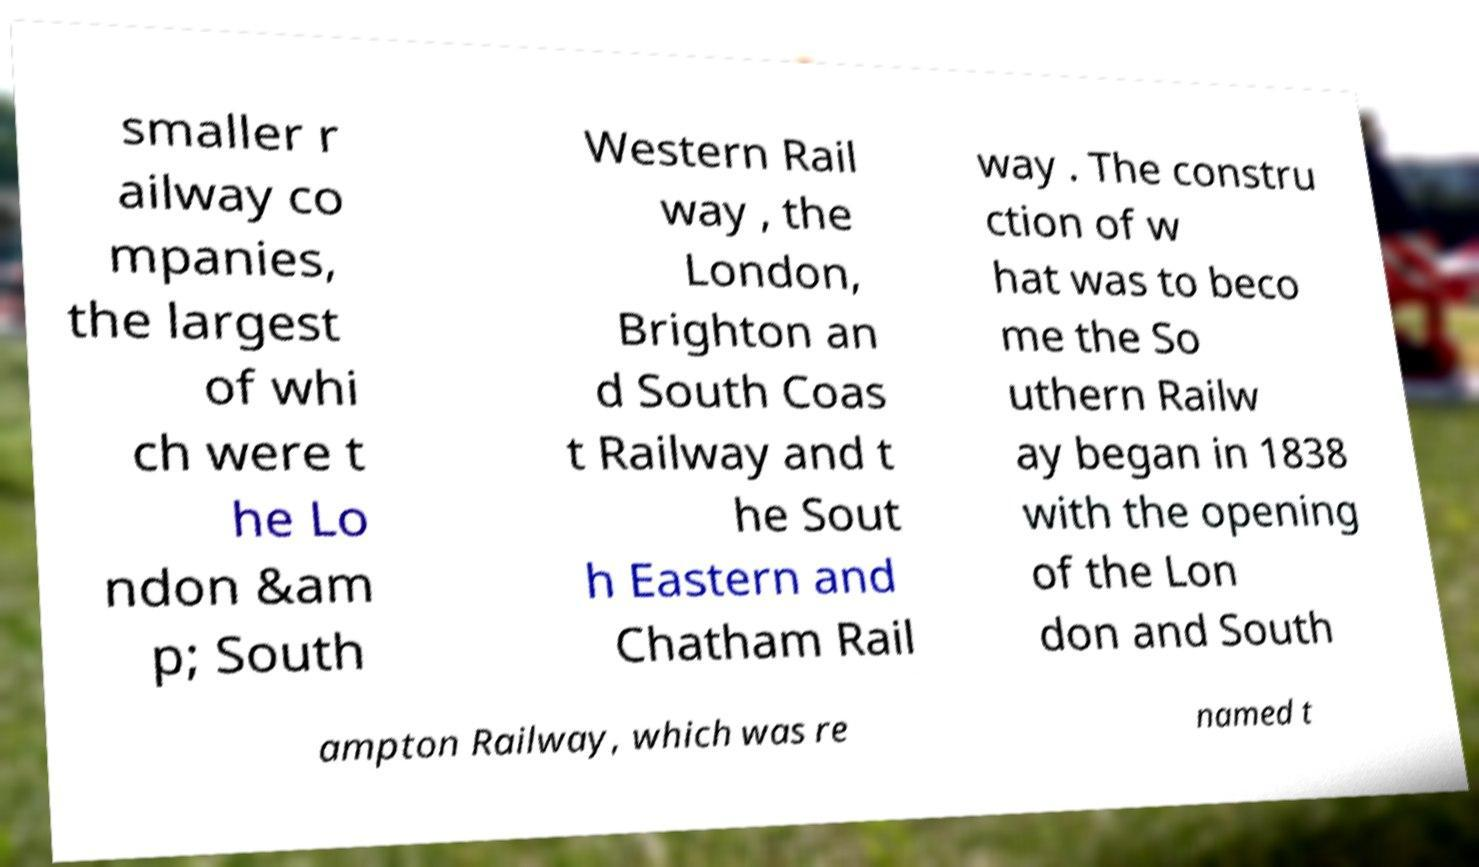Please identify and transcribe the text found in this image. smaller r ailway co mpanies, the largest of whi ch were t he Lo ndon &am p; South Western Rail way , the London, Brighton an d South Coas t Railway and t he Sout h Eastern and Chatham Rail way . The constru ction of w hat was to beco me the So uthern Railw ay began in 1838 with the opening of the Lon don and South ampton Railway, which was re named t 